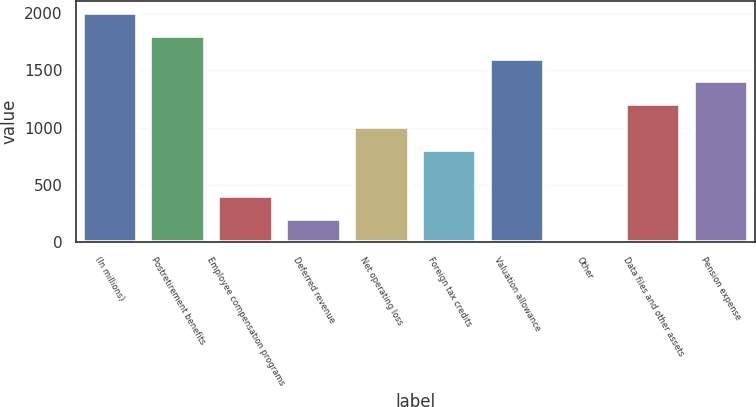Convert chart to OTSL. <chart><loc_0><loc_0><loc_500><loc_500><bar_chart><fcel>(In millions)<fcel>Postretirement benefits<fcel>Employee compensation programs<fcel>Deferred revenue<fcel>Net operating loss<fcel>Foreign tax credits<fcel>Valuation allowance<fcel>Other<fcel>Data files and other assets<fcel>Pension expense<nl><fcel>2002<fcel>1802.3<fcel>404.4<fcel>204.7<fcel>1003.5<fcel>803.8<fcel>1602.6<fcel>5<fcel>1203.2<fcel>1402.9<nl></chart> 